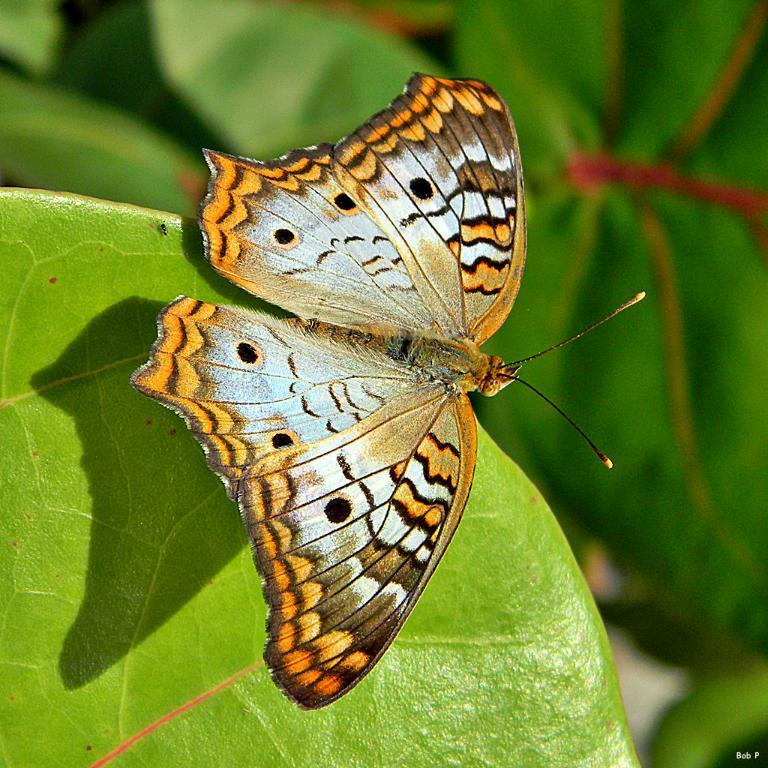What is the main subject of the image? There is a butterfly on a leaf in the image. Can you describe the background of the image? The background of the image is blurred. How many sisters are sitting on the plane in the image? There are no sisters or planes present in the image; it features a butterfly on a leaf with a blurred background. Who is the expert in the image? There is no expert present in the image; it features a butterfly on a leaf with a blurred background. 